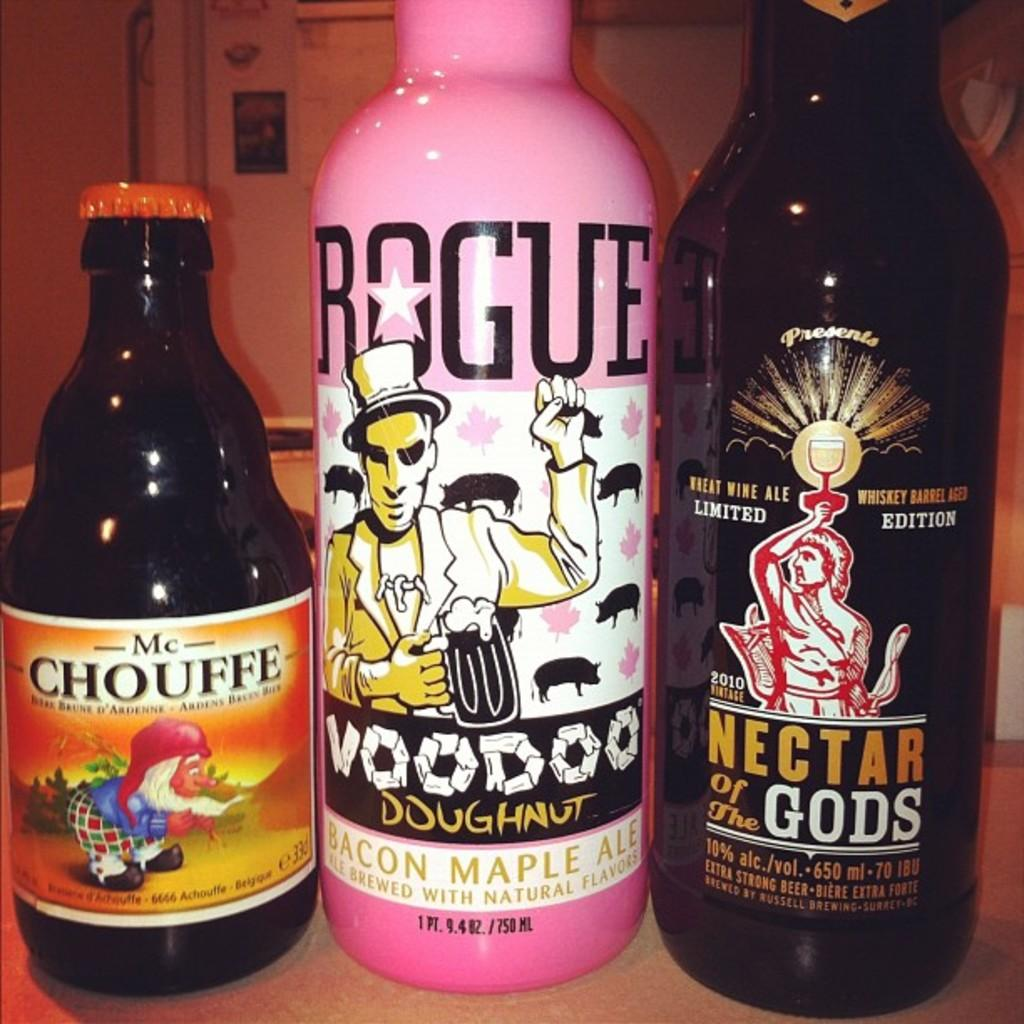<image>
Summarize the visual content of the image. Three different beverages are next to each other, one of which is made by Rogue. 